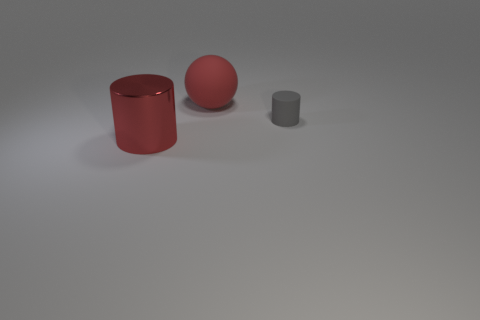What is the shape of the metallic object that is the same color as the sphere?
Offer a terse response. Cylinder. Is the number of large red shiny objects that are behind the rubber cylinder the same as the number of small things that are in front of the large ball?
Keep it short and to the point. No. What is the shape of the rubber thing behind the cylinder right of the big red metallic cylinder?
Your answer should be compact. Sphere. What material is the other gray thing that is the same shape as the large shiny object?
Your answer should be very brief. Rubber. What color is the thing that is the same size as the matte sphere?
Offer a very short reply. Red. Are there an equal number of big cylinders right of the big red rubber object and large purple things?
Provide a succinct answer. Yes. The big metallic object in front of the big red object right of the red metallic cylinder is what color?
Provide a succinct answer. Red. How big is the matte thing in front of the big thing behind the big red metal cylinder?
Give a very brief answer. Small. There is a cylinder that is the same color as the big matte thing; what is its size?
Make the answer very short. Large. What number of other things are there of the same size as the shiny cylinder?
Ensure brevity in your answer.  1. 